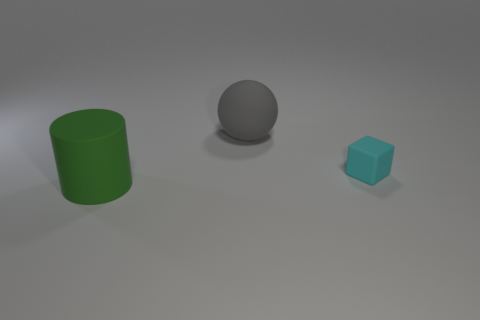Is there a big green rubber cylinder behind the large matte object right of the matte object left of the big sphere?
Your answer should be compact. No. Do the green rubber thing in front of the small rubber thing and the large thing right of the big green cylinder have the same shape?
Your answer should be compact. No. Are there more small matte blocks on the left side of the gray rubber sphere than cyan matte things?
Your response must be concise. No. What number of things are either tiny cyan objects or big purple metallic cylinders?
Offer a very short reply. 1. The rubber cube has what color?
Ensure brevity in your answer.  Cyan. What number of other things are the same color as the tiny thing?
Give a very brief answer. 0. Are there any green cylinders behind the gray object?
Provide a succinct answer. No. What color is the large object behind the large rubber thing that is to the left of the matte object that is behind the cyan rubber cube?
Give a very brief answer. Gray. How many things are behind the green rubber cylinder and in front of the large gray thing?
Give a very brief answer. 1. What number of blocks are small red things or large things?
Offer a very short reply. 0. 